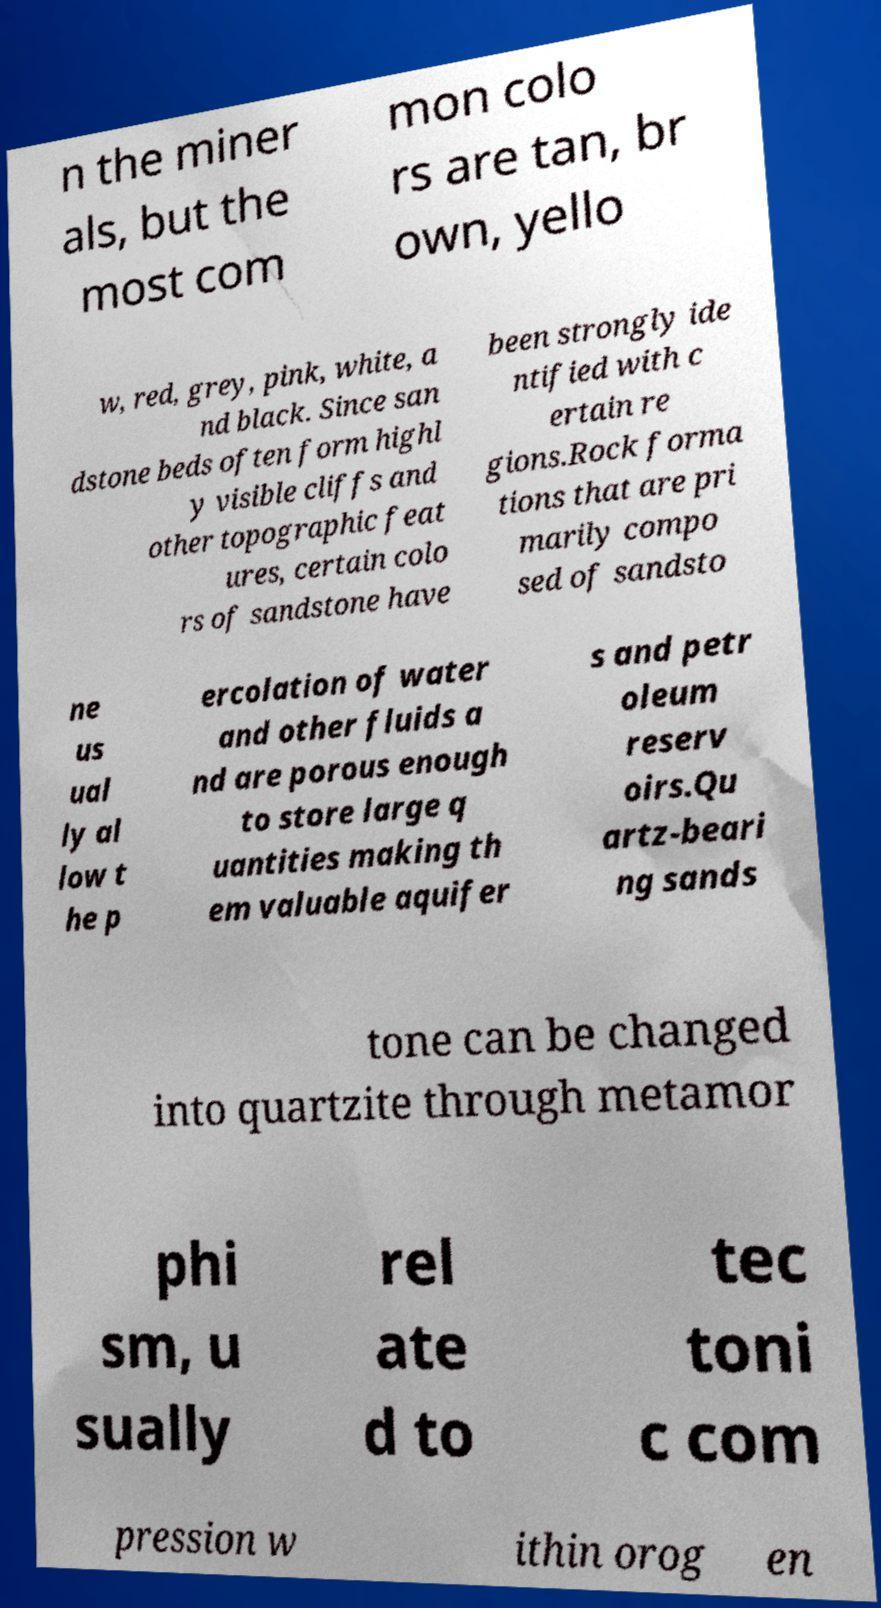I need the written content from this picture converted into text. Can you do that? n the miner als, but the most com mon colo rs are tan, br own, yello w, red, grey, pink, white, a nd black. Since san dstone beds often form highl y visible cliffs and other topographic feat ures, certain colo rs of sandstone have been strongly ide ntified with c ertain re gions.Rock forma tions that are pri marily compo sed of sandsto ne us ual ly al low t he p ercolation of water and other fluids a nd are porous enough to store large q uantities making th em valuable aquifer s and petr oleum reserv oirs.Qu artz-beari ng sands tone can be changed into quartzite through metamor phi sm, u sually rel ate d to tec toni c com pression w ithin orog en 